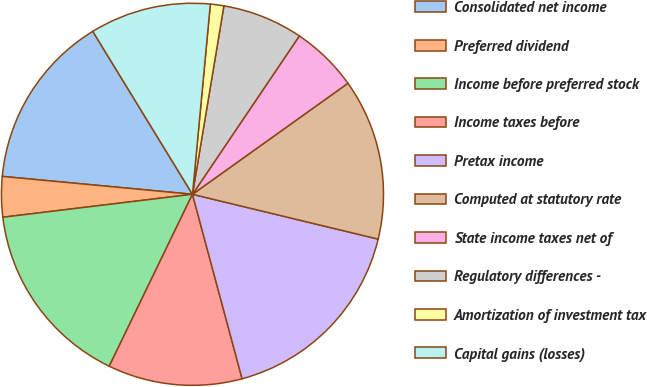<chart> <loc_0><loc_0><loc_500><loc_500><pie_chart><fcel>Consolidated net income<fcel>Preferred dividend<fcel>Income before preferred stock<fcel>Income taxes before<fcel>Pretax income<fcel>Computed at statutory rate<fcel>State income taxes net of<fcel>Regulatory differences -<fcel>Amortization of investment tax<fcel>Capital gains (losses)<nl><fcel>14.77%<fcel>3.41%<fcel>15.91%<fcel>11.36%<fcel>17.05%<fcel>13.64%<fcel>5.68%<fcel>6.82%<fcel>1.14%<fcel>10.23%<nl></chart> 